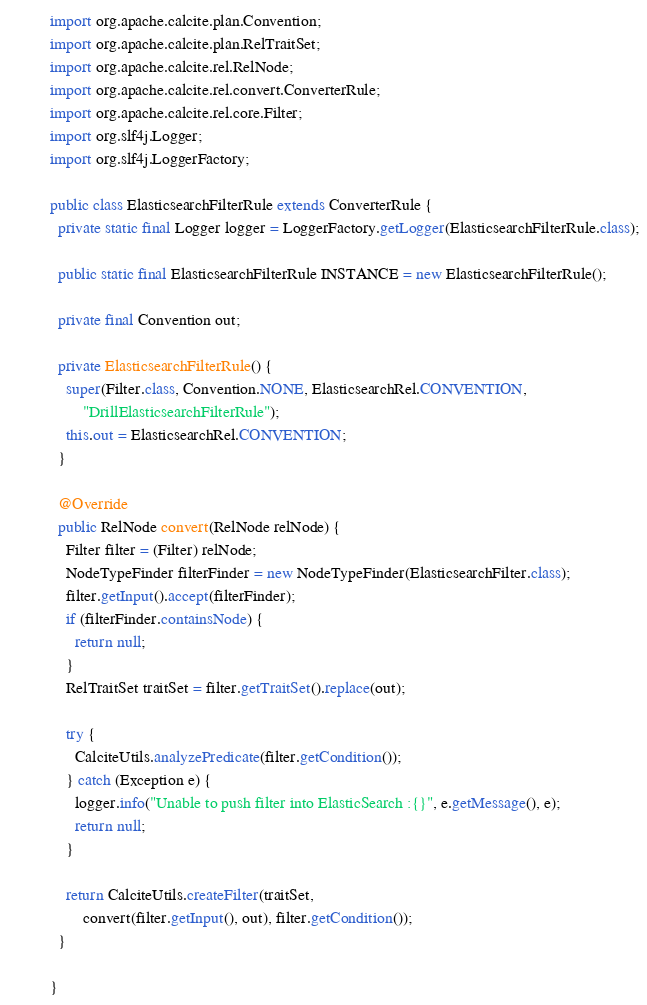Convert code to text. <code><loc_0><loc_0><loc_500><loc_500><_Java_>import org.apache.calcite.plan.Convention;
import org.apache.calcite.plan.RelTraitSet;
import org.apache.calcite.rel.RelNode;
import org.apache.calcite.rel.convert.ConverterRule;
import org.apache.calcite.rel.core.Filter;
import org.slf4j.Logger;
import org.slf4j.LoggerFactory;

public class ElasticsearchFilterRule extends ConverterRule {
  private static final Logger logger = LoggerFactory.getLogger(ElasticsearchFilterRule.class);

  public static final ElasticsearchFilterRule INSTANCE = new ElasticsearchFilterRule();

  private final Convention out;

  private ElasticsearchFilterRule() {
    super(Filter.class, Convention.NONE, ElasticsearchRel.CONVENTION,
        "DrillElasticsearchFilterRule");
    this.out = ElasticsearchRel.CONVENTION;
  }

  @Override
  public RelNode convert(RelNode relNode) {
    Filter filter = (Filter) relNode;
    NodeTypeFinder filterFinder = new NodeTypeFinder(ElasticsearchFilter.class);
    filter.getInput().accept(filterFinder);
    if (filterFinder.containsNode) {
      return null;
    }
    RelTraitSet traitSet = filter.getTraitSet().replace(out);

    try {
      CalciteUtils.analyzePredicate(filter.getCondition());
    } catch (Exception e) {
      logger.info("Unable to push filter into ElasticSearch :{}", e.getMessage(), e);
      return null;
    }

    return CalciteUtils.createFilter(traitSet,
        convert(filter.getInput(), out), filter.getCondition());
  }

}
</code> 